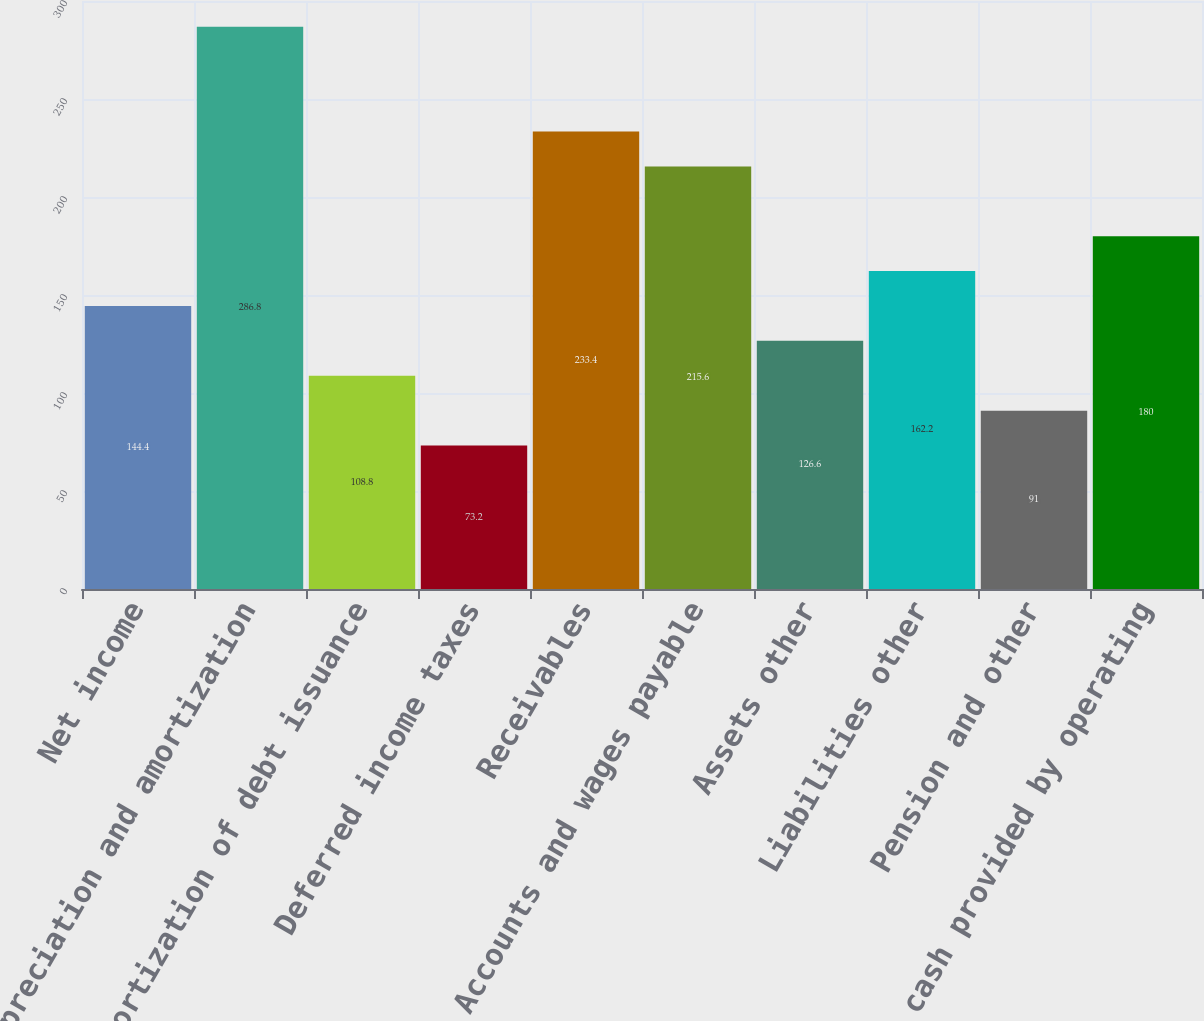Convert chart to OTSL. <chart><loc_0><loc_0><loc_500><loc_500><bar_chart><fcel>Net income<fcel>Depreciation and amortization<fcel>Amortization of debt issuance<fcel>Deferred income taxes<fcel>Receivables<fcel>Accounts and wages payable<fcel>Assets other<fcel>Liabilities other<fcel>Pension and other<fcel>Net cash provided by operating<nl><fcel>144.4<fcel>286.8<fcel>108.8<fcel>73.2<fcel>233.4<fcel>215.6<fcel>126.6<fcel>162.2<fcel>91<fcel>180<nl></chart> 